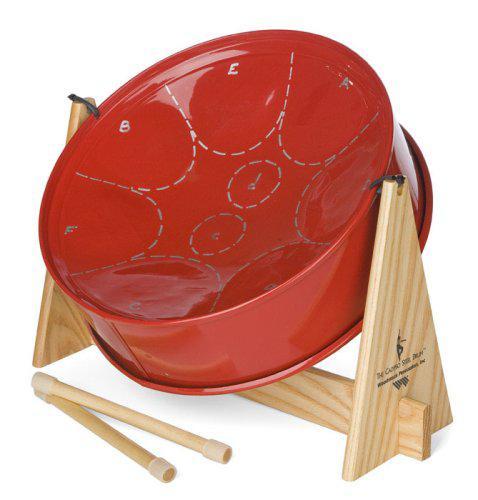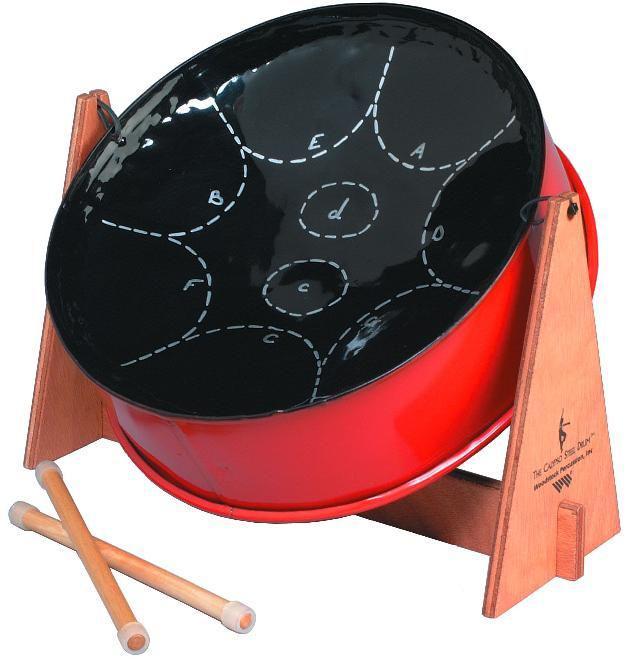The first image is the image on the left, the second image is the image on the right. Assess this claim about the two images: "All the drumsticks are resting on the drum head.". Correct or not? Answer yes or no. No. The first image is the image on the left, the second image is the image on the right. For the images displayed, is the sentence "Each image shows one tilted cylindrical bowl-type drum on a pivoting stand, and the drum on the right has a red exterior and black bowl top." factually correct? Answer yes or no. Yes. 